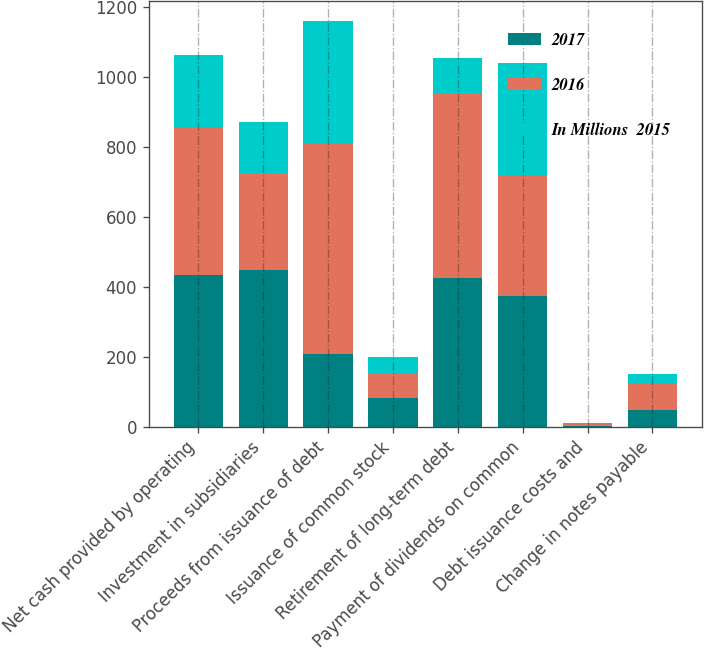<chart> <loc_0><loc_0><loc_500><loc_500><stacked_bar_chart><ecel><fcel>Net cash provided by operating<fcel>Investment in subsidiaries<fcel>Proceeds from issuance of debt<fcel>Issuance of common stock<fcel>Retirement of long-term debt<fcel>Payment of dividends on common<fcel>Debt issuance costs and<fcel>Change in notes payable<nl><fcel>2017<fcel>433<fcel>447<fcel>209<fcel>83<fcel>425<fcel>375<fcel>3<fcel>47<nl><fcel>2016<fcel>422<fcel>275<fcel>603<fcel>72<fcel>530<fcel>345<fcel>5<fcel>76<nl><fcel>In Millions  2015<fcel>209<fcel>150<fcel>349<fcel>43<fcel>100<fcel>320<fcel>3<fcel>28<nl></chart> 